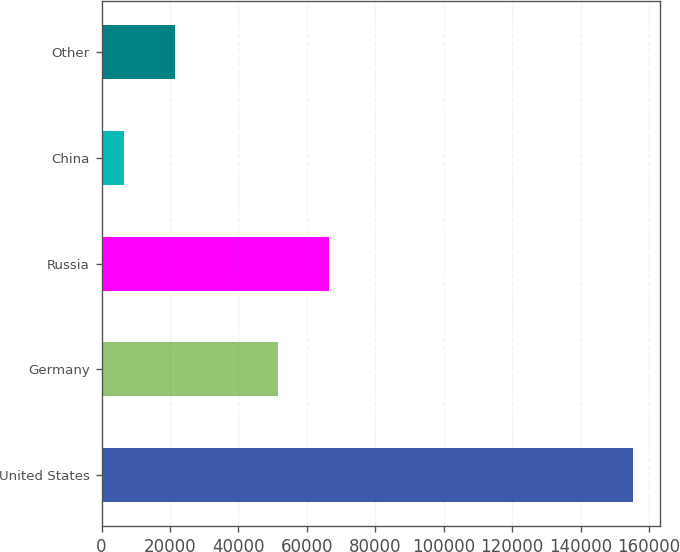Convert chart. <chart><loc_0><loc_0><loc_500><loc_500><bar_chart><fcel>United States<fcel>Germany<fcel>Russia<fcel>China<fcel>Other<nl><fcel>155428<fcel>51528<fcel>66412.6<fcel>6582<fcel>21466.6<nl></chart> 